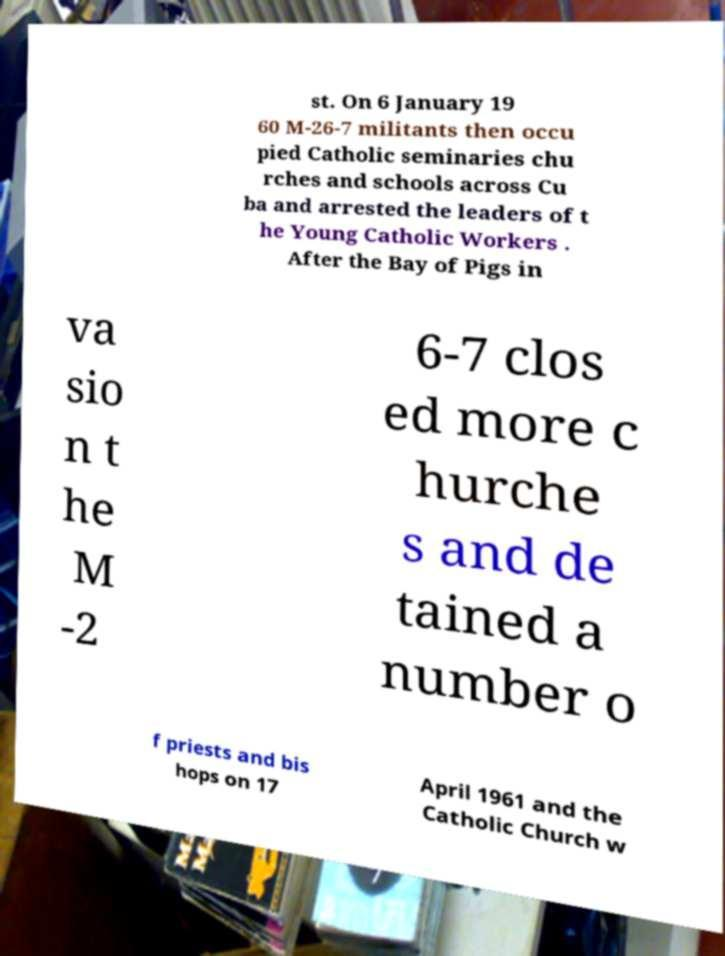Can you accurately transcribe the text from the provided image for me? st. On 6 January 19 60 M-26-7 militants then occu pied Catholic seminaries chu rches and schools across Cu ba and arrested the leaders of t he Young Catholic Workers . After the Bay of Pigs in va sio n t he M -2 6-7 clos ed more c hurche s and de tained a number o f priests and bis hops on 17 April 1961 and the Catholic Church w 